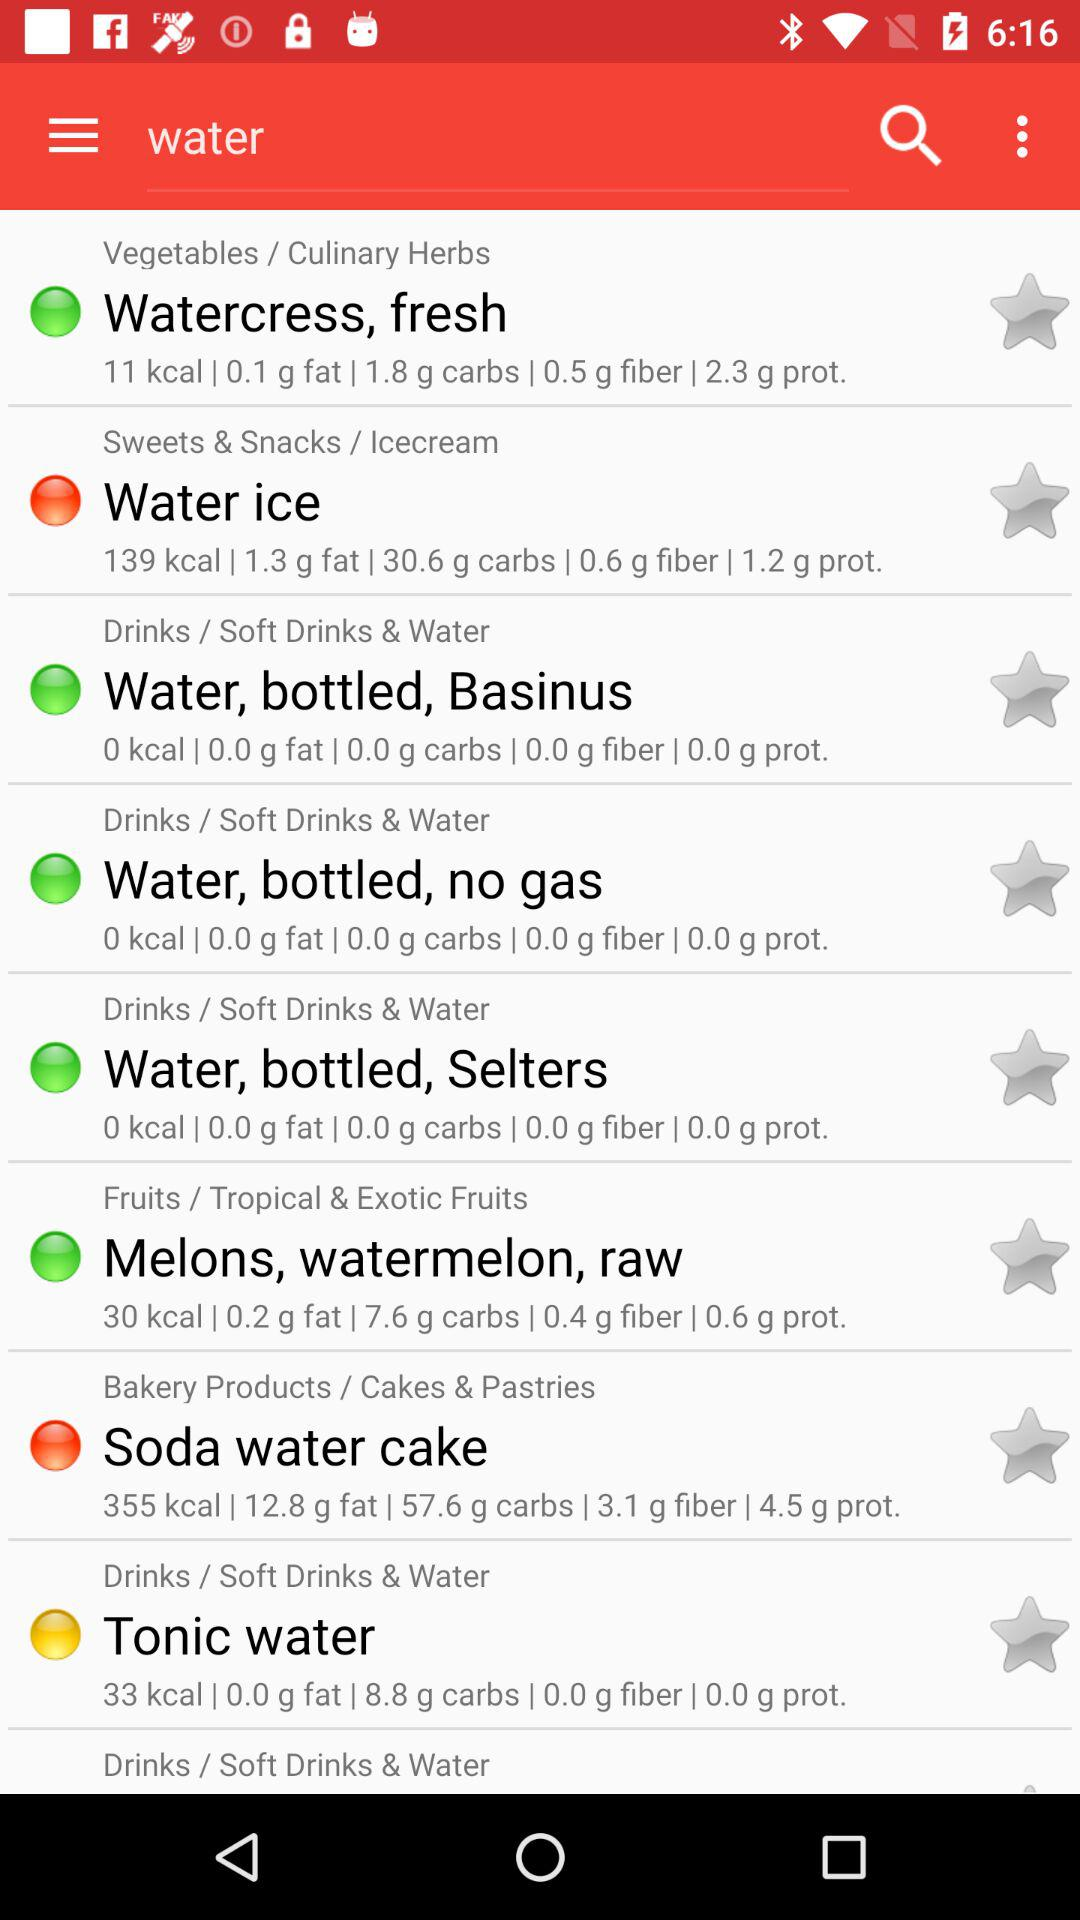139 calories are present in which water?
When the provided information is insufficient, respond with <no answer>. <no answer> 